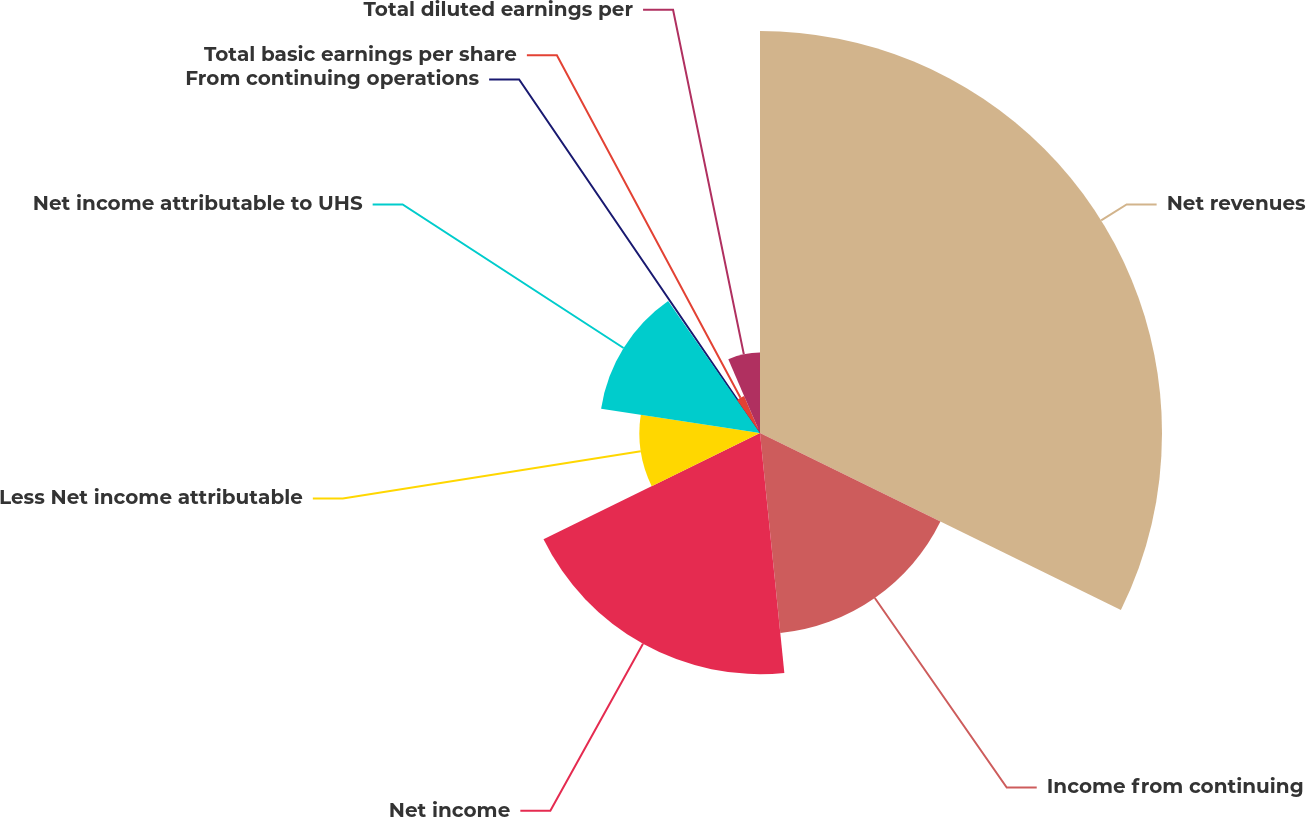Convert chart. <chart><loc_0><loc_0><loc_500><loc_500><pie_chart><fcel>Net revenues<fcel>Income from continuing<fcel>Net income<fcel>Less Net income attributable<fcel>Net income attributable to UHS<fcel>From continuing operations<fcel>Total basic earnings per share<fcel>Total diluted earnings per<nl><fcel>32.26%<fcel>16.13%<fcel>19.35%<fcel>9.68%<fcel>12.9%<fcel>0.0%<fcel>3.23%<fcel>6.45%<nl></chart> 